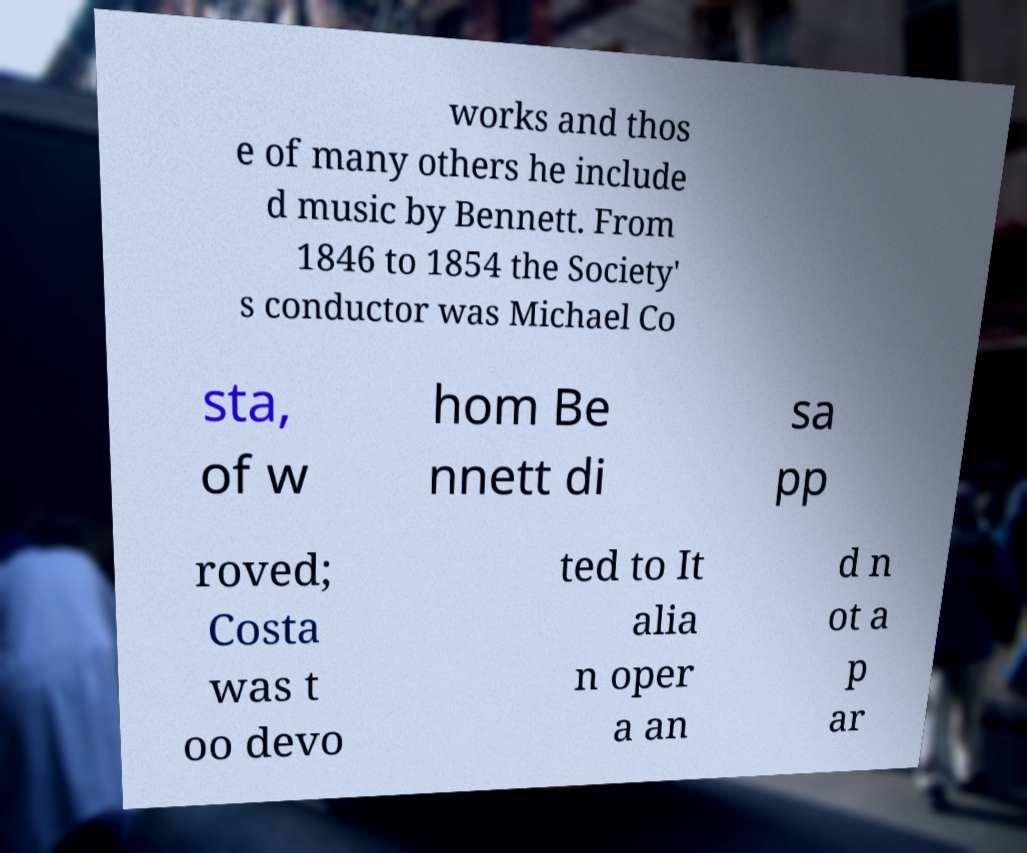There's text embedded in this image that I need extracted. Can you transcribe it verbatim? works and thos e of many others he include d music by Bennett. From 1846 to 1854 the Society' s conductor was Michael Co sta, of w hom Be nnett di sa pp roved; Costa was t oo devo ted to It alia n oper a an d n ot a p ar 